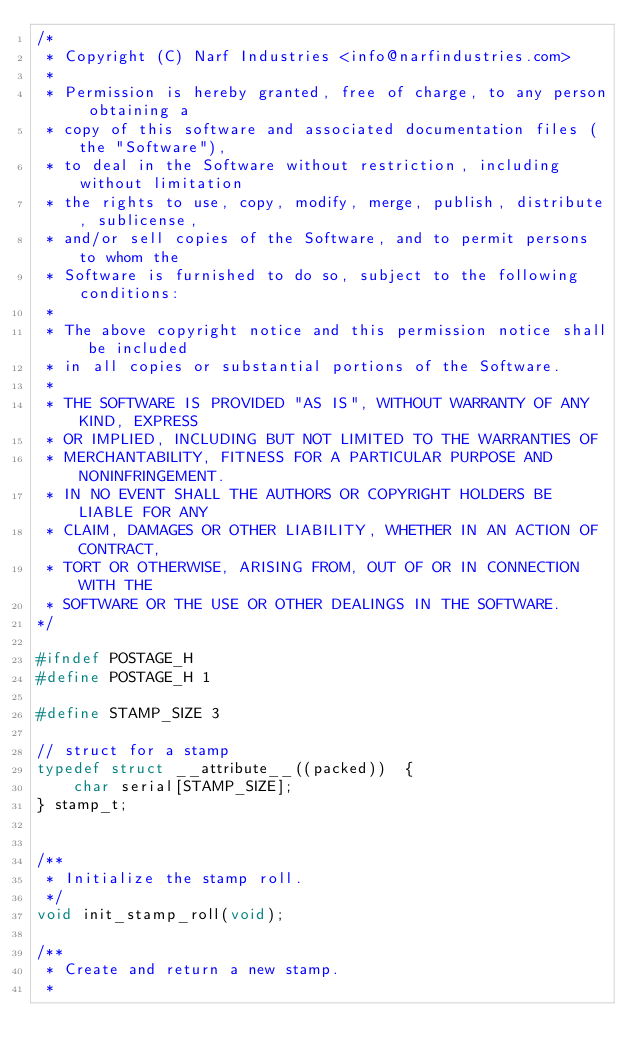Convert code to text. <code><loc_0><loc_0><loc_500><loc_500><_C_>/*
 * Copyright (C) Narf Industries <info@narfindustries.com>
 *
 * Permission is hereby granted, free of charge, to any person obtaining a
 * copy of this software and associated documentation files (the "Software"),
 * to deal in the Software without restriction, including without limitation
 * the rights to use, copy, modify, merge, publish, distribute, sublicense,
 * and/or sell copies of the Software, and to permit persons to whom the
 * Software is furnished to do so, subject to the following conditions:
 *
 * The above copyright notice and this permission notice shall be included
 * in all copies or substantial portions of the Software.
 *
 * THE SOFTWARE IS PROVIDED "AS IS", WITHOUT WARRANTY OF ANY KIND, EXPRESS
 * OR IMPLIED, INCLUDING BUT NOT LIMITED TO THE WARRANTIES OF
 * MERCHANTABILITY, FITNESS FOR A PARTICULAR PURPOSE AND NONINFRINGEMENT.
 * IN NO EVENT SHALL THE AUTHORS OR COPYRIGHT HOLDERS BE LIABLE FOR ANY
 * CLAIM, DAMAGES OR OTHER LIABILITY, WHETHER IN AN ACTION OF CONTRACT,
 * TORT OR OTHERWISE, ARISING FROM, OUT OF OR IN CONNECTION WITH THE
 * SOFTWARE OR THE USE OR OTHER DEALINGS IN THE SOFTWARE.
*/

#ifndef POSTAGE_H
#define POSTAGE_H 1

#define STAMP_SIZE 3

// struct for a stamp
typedef struct __attribute__((packed))  {
	char serial[STAMP_SIZE];
} stamp_t;


/**
 * Initialize the stamp roll.
 */
void init_stamp_roll(void);

/**
 * Create and return a new stamp.
 *</code> 